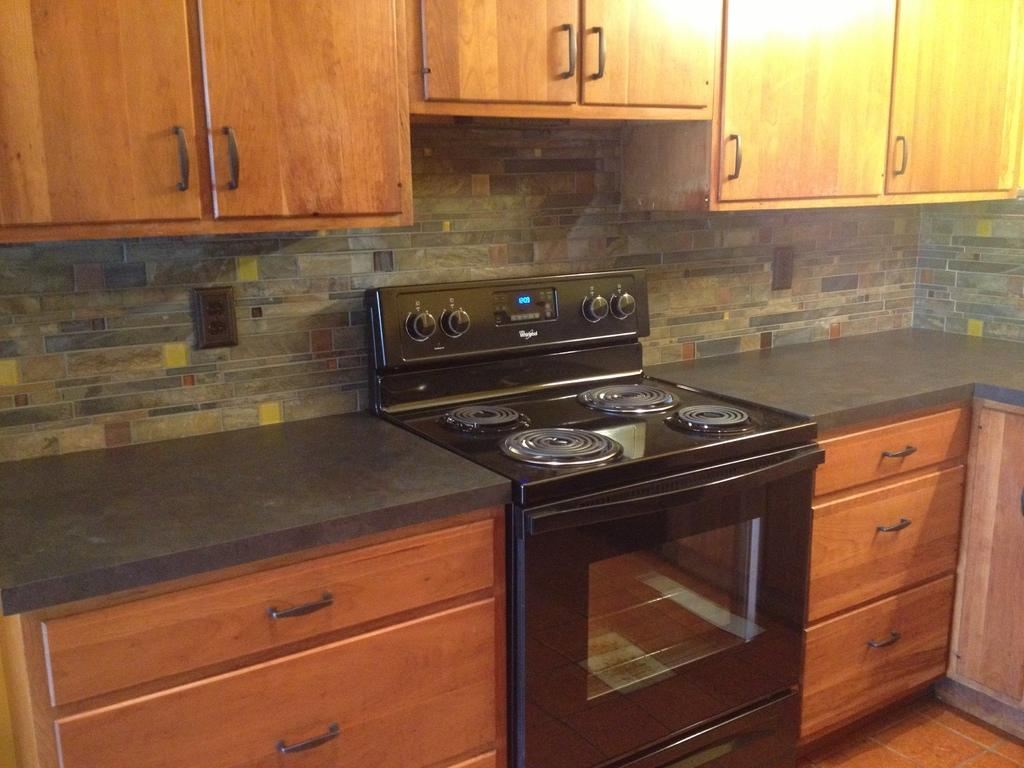What color is the stove in the image? The stove in the image is black. What appliance is located next to the stove? There is a microwave in the image. What type of storage units are present on either side of the stove and microwave? There are cupboards on either side of the stove and microwave. Are there any cupboards above the stove and microwave? Yes, there are cupboards above the stove and microwave. What type of brass bird is sitting on the stove in the image? There is no brass bird present in the image; it only features a black stove, a microwave, and cupboards. 